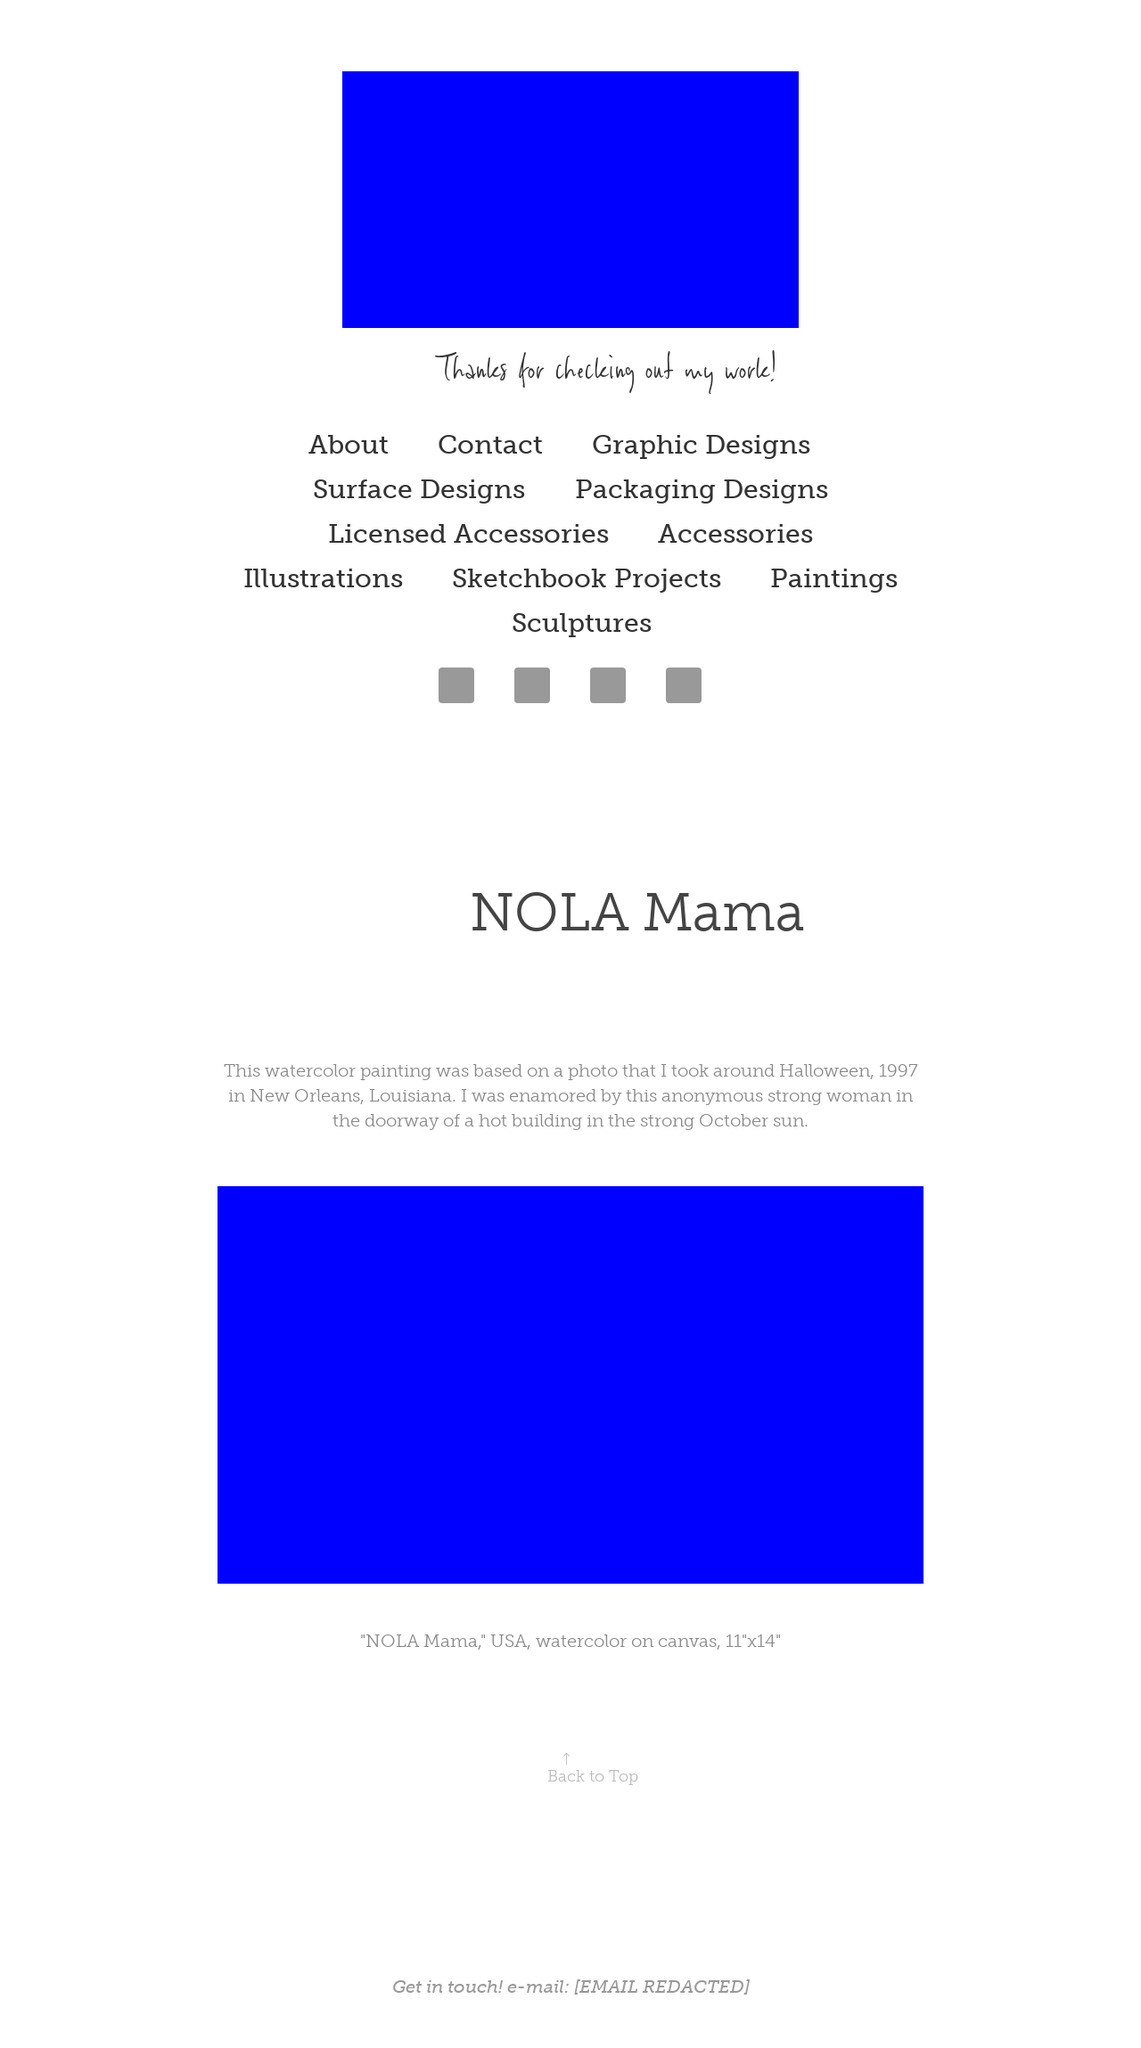What's the procedure for constructing this website from scratch with HTML? To construct a website from scratch using HTML, begin by creating a basic HTML structure with <!DOCTYPE html>, <html>, <head>, and <body> tags. Include essential elements like <title> for page title and <meta> tags for metadata. Next, create the body of the website using tags such as <header>, <nav> for navigation links, and <div> elements to structure different sections. Use <img> tags to insert images and <p> for text paragraphs to enrich content. Finally, style your website using CSS to adjust layouts, colors, and fonts, ensuring it reflects the desired artistic theme and functionality. 